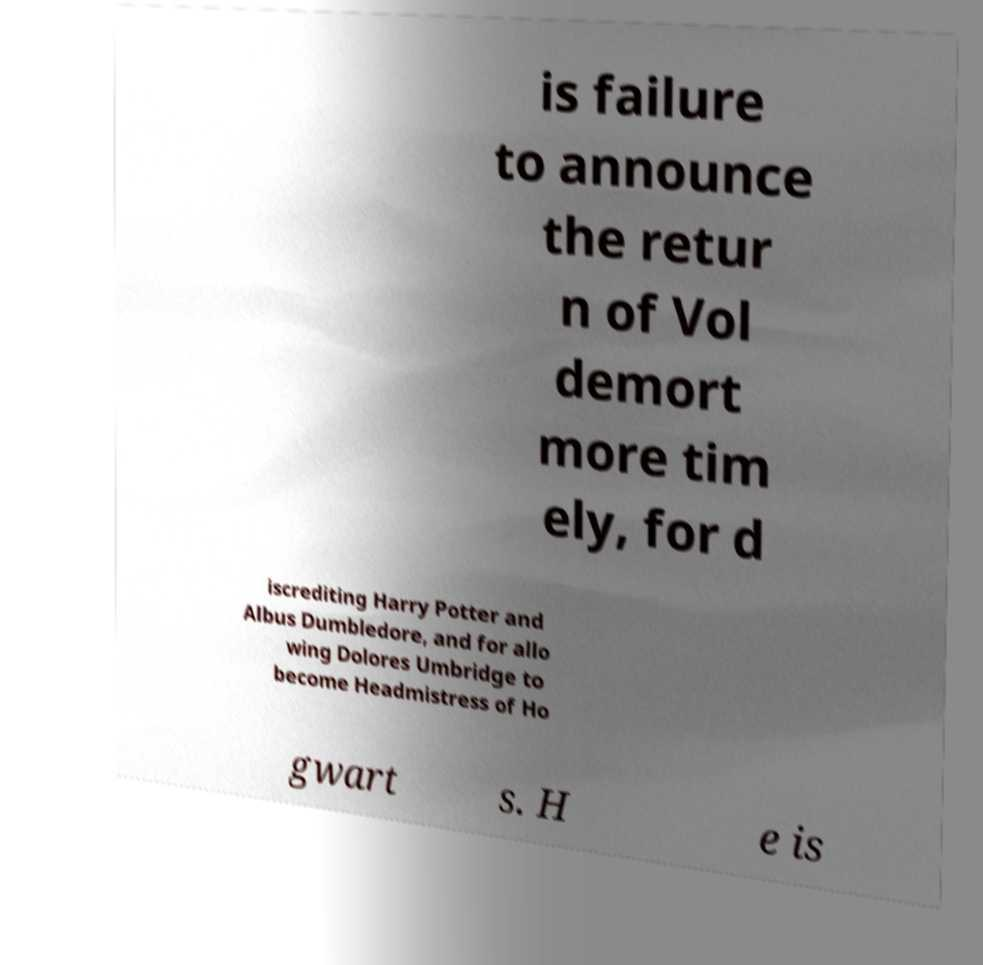Could you assist in decoding the text presented in this image and type it out clearly? is failure to announce the retur n of Vol demort more tim ely, for d iscrediting Harry Potter and Albus Dumbledore, and for allo wing Dolores Umbridge to become Headmistress of Ho gwart s. H e is 